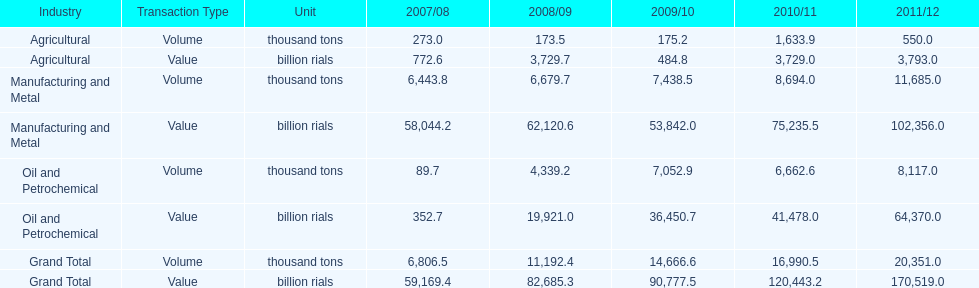In how many years was the value of agriculture, in billion rials, greater than 500 in iran? 4. Can you parse all the data within this table? {'header': ['Industry', 'Transaction Type', 'Unit', '2007/08', '2008/09', '2009/10', '2010/11', '2011/12'], 'rows': [['Agricultural', 'Volume', 'thousand tons', '273.0', '173.5', '175.2', '1,633.9', '550.0'], ['Agricultural', 'Value', 'billion rials', '772.6', '3,729.7', '484.8', '3,729.0', '3,793.0'], ['Manufacturing and Metal', 'Volume', 'thousand tons', '6,443.8', '6,679.7', '7,438.5', '8,694.0', '11,685.0'], ['Manufacturing and Metal', 'Value', 'billion rials', '58,044.2', '62,120.6', '53,842.0', '75,235.5', '102,356.0'], ['Oil and Petrochemical', 'Volume', 'thousand tons', '89.7', '4,339.2', '7,052.9', '6,662.6', '8,117.0'], ['Oil and Petrochemical', 'Value', 'billion rials', '352.7', '19,921.0', '36,450.7', '41,478.0', '64,370.0'], ['Grand Total', 'Volume', 'thousand tons', '6,806.5', '11,192.4', '14,666.6', '16,990.5', '20,351.0'], ['Grand Total', 'Value', 'billion rials', '59,169.4', '82,685.3', '90,777.5', '120,443.2', '170,519.0']]} 